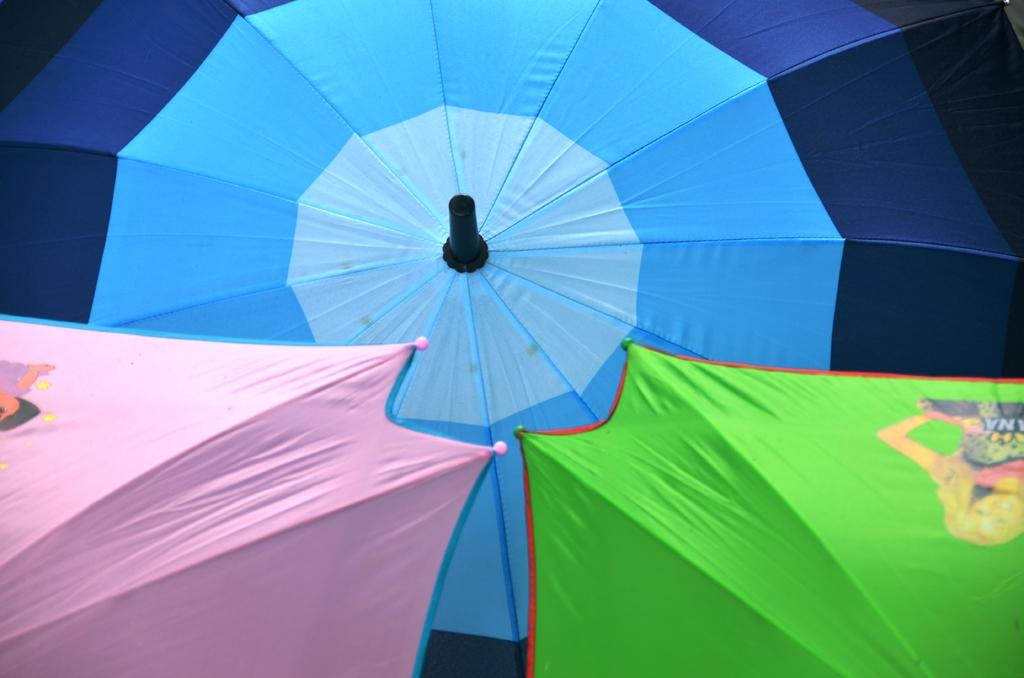How many umbrellas are in the picture? There are 3 umbrellas in the picture. What colors are the umbrellas? One umbrella is pink, one is green, and one is blue. Are there any umbrellas with specific designs on them? Yes, two umbrellas have cartoon characters on them. Is there any grass visible in the picture? There is no grass present in the image; it only features umbrellas. What season is depicted in the image? The image does not depict a specific season, as there are no seasonal cues present. 